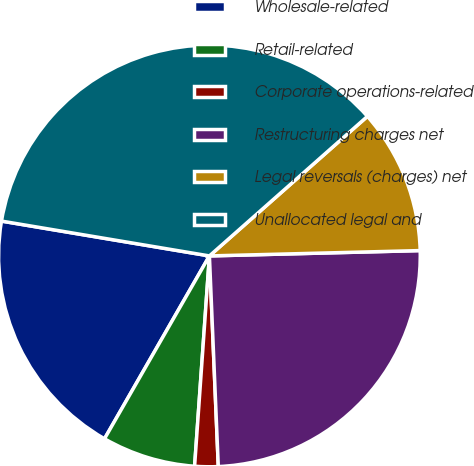Convert chart. <chart><loc_0><loc_0><loc_500><loc_500><pie_chart><fcel>Wholesale-related<fcel>Retail-related<fcel>Corporate operations-related<fcel>Restructuring charges net<fcel>Legal reversals (charges) net<fcel>Unallocated legal and<nl><fcel>19.35%<fcel>7.17%<fcel>1.79%<fcel>24.73%<fcel>11.11%<fcel>35.84%<nl></chart> 